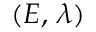<formula> <loc_0><loc_0><loc_500><loc_500>( E , \, \lambda )</formula> 